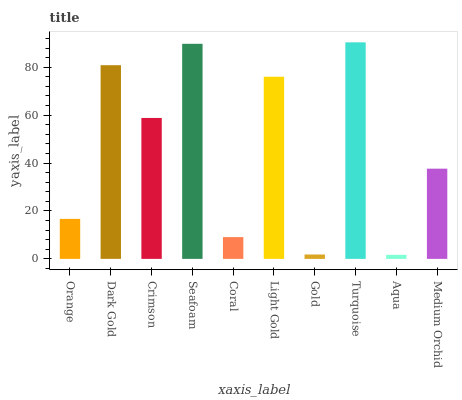Is Aqua the minimum?
Answer yes or no. Yes. Is Turquoise the maximum?
Answer yes or no. Yes. Is Dark Gold the minimum?
Answer yes or no. No. Is Dark Gold the maximum?
Answer yes or no. No. Is Dark Gold greater than Orange?
Answer yes or no. Yes. Is Orange less than Dark Gold?
Answer yes or no. Yes. Is Orange greater than Dark Gold?
Answer yes or no. No. Is Dark Gold less than Orange?
Answer yes or no. No. Is Crimson the high median?
Answer yes or no. Yes. Is Medium Orchid the low median?
Answer yes or no. Yes. Is Light Gold the high median?
Answer yes or no. No. Is Coral the low median?
Answer yes or no. No. 